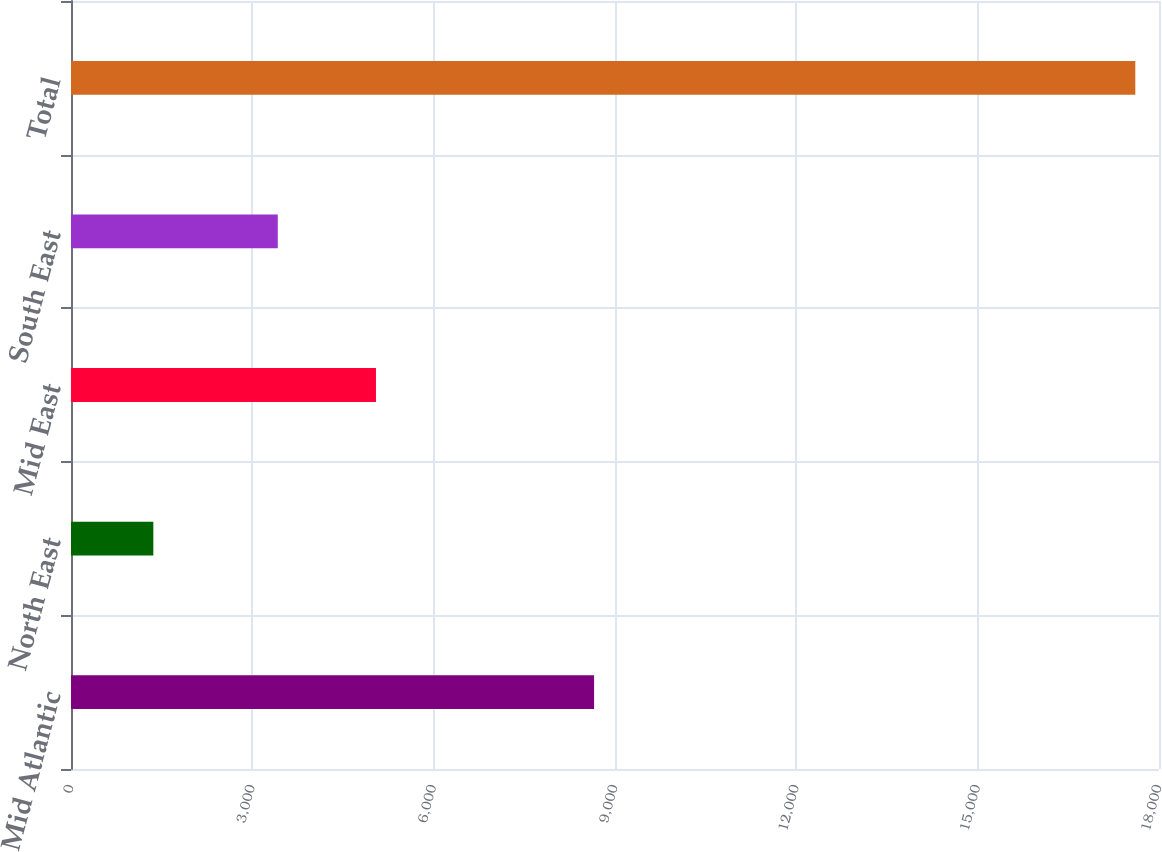<chart> <loc_0><loc_0><loc_500><loc_500><bar_chart><fcel>Mid Atlantic<fcel>North East<fcel>Mid East<fcel>South East<fcel>Total<nl><fcel>8654<fcel>1362<fcel>5045.6<fcel>3421<fcel>17608<nl></chart> 